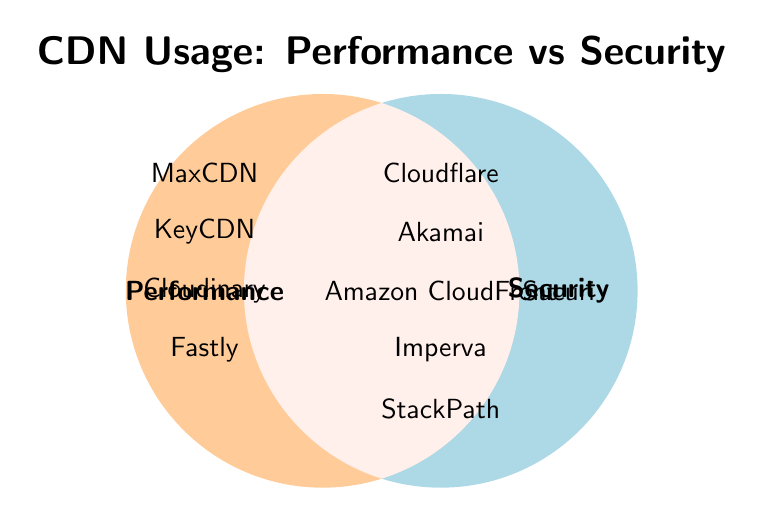What is the title of the figure? The title is found at the top of the figure and indicates the overall topic it represents.
Answer: CDN Usage: Performance vs Security Which CDN providers are listed in both circles? CDNs listed inside both circles provide both performance and security benefits.
Answer: Cloudflare, Akamai, Amazon CloudFront, Imperva, StackPath Which CDN providers are listed only for performance? CDNs listed only in the performance circle provide performance benefits but not security.
Answer: Fastly, MaxCDN, KeyCDN, Cloudinary Which CDN is listed only under security? The CDN listed outside both circles but near the security label provides security benefits only.
Answer: Sucuri How many CDN providers offer both performance and security benefits? Count the number of names located in the intersection of both circles. There are 5 names.
Answer: 5 Which CDNs do not offer performance benefits? List the CDNs not present in the performance circle.
Answer: Sucuri Compare the number of CDNs offering only performance with those offering both performance and security. Which group is larger? Calculate and compare the counts of CDNs inside the performance-only circle and the intersection. Performance-only has 4 names and the intersection has 5 names.
Answer: Both performance and security Identify the CDN providers that are listed outside both circles. Check if any names are entirely outside the drawn circles.
Answer: None Which CDNs provide only performance and not security? Identify CDNs present only in the performance circle and not the intersection.
Answer: Fastly, MaxCDN, KeyCDN, Cloudinary Do more CDN providers offer performance benefits or security benefits exclusively? Sum the exclusive lists for each category. Performance-only has 4 and security-only has 1.
Answer: Performance 